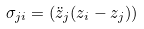Convert formula to latex. <formula><loc_0><loc_0><loc_500><loc_500>\sigma _ { j i } = \left ( \ddot { z } _ { j } ( z _ { i } - z _ { j } ) \right )</formula> 